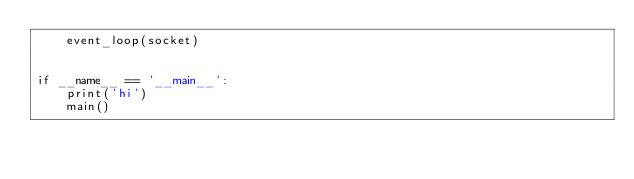Convert code to text. <code><loc_0><loc_0><loc_500><loc_500><_Python_>    event_loop(socket)


if __name__ == '__main__':
    print('hi')
    main()
</code> 